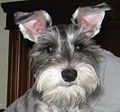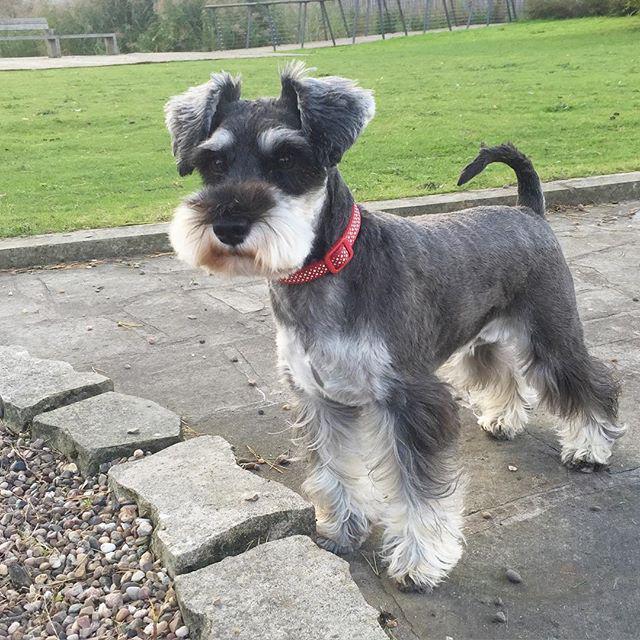The first image is the image on the left, the second image is the image on the right. For the images displayed, is the sentence "There are two dogs sitting down." factually correct? Answer yes or no. No. The first image is the image on the left, the second image is the image on the right. Evaluate the accuracy of this statement regarding the images: "There is a dog wearing a collar and facing left in one image.". Is it true? Answer yes or no. Yes. 